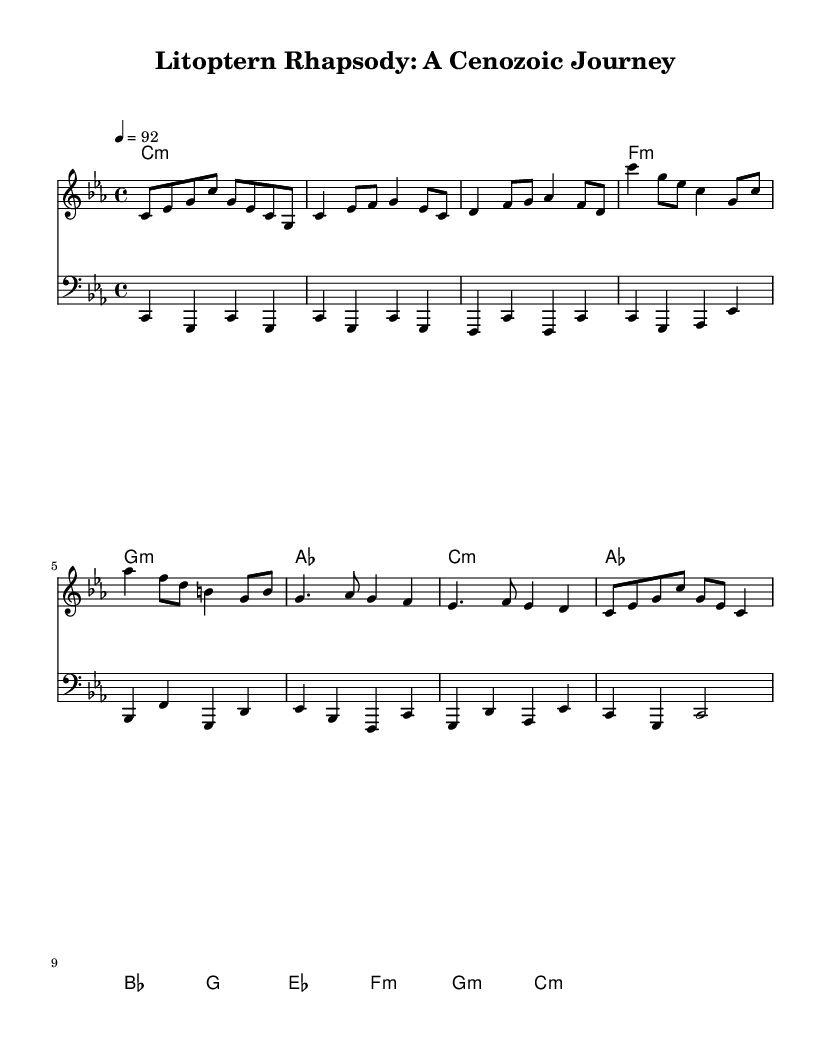What is the key signature of this music? The key signature is C minor, which has three flats (B♭, E♭, A♭). This can be deduced from the initial notation at the beginning of the piece showing the key signature in the staff lines.
Answer: C minor What is the time signature of this music? The time signature is 4/4, indicating that there are four beats in each measure and the quarter note receives one beat. This is evident from the notation "4/4" located at the beginning of the score.
Answer: 4/4 What is the tempo marking given for the piece? The tempo marking indicated is "4 = 92", meaning that there are 92 beats per minute at quarter note speed. This information is located at the beginning of the score as part of the global settings.
Answer: 92 How many measures are in the chorus section? In the score, the chorus is 2 measures long, as identified by the specific section structure where the corresponding melody and harmony align within the staff.
Answer: 2 How many distinct sections does the piece have? The piece has 5 distinct sections: Intro, Verse, Chorus, Bridge, and Outro. This can be confirmed by analyzing the overall structure laid out in the sheet music and observing the flow from one section to another.
Answer: 5 Which chord is used in the Bridge section? The chords used in the Bridge section include E♭ major, F minor, G minor, and C minor. Identifying these can be easily done by looking at the chord symbols written above the staff for that specific section.
Answer: E♭ major What is the genre of this piece of music? The genre is Rap, as indicated by the content and style of the lyrics, as well as the rhythmic and lyrical structure typical of hip-hop music. The overall representation in the title suggests this genre effectively.
Answer: Rap 